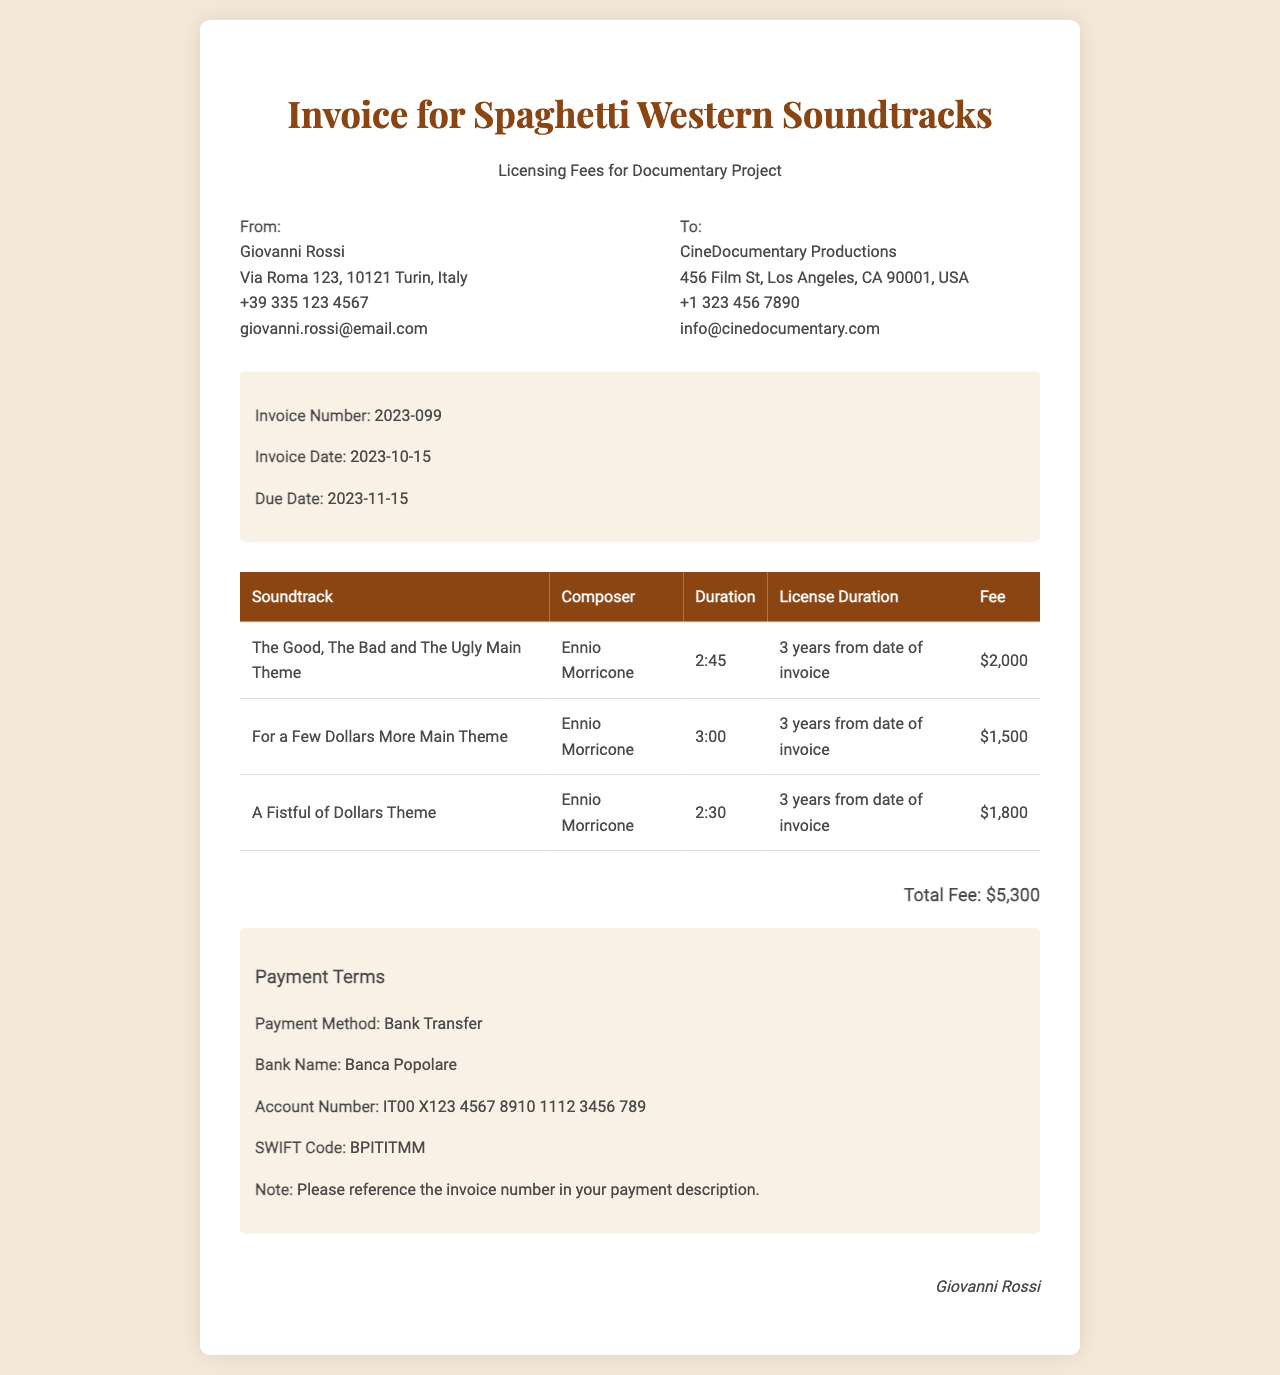What is the invoice number? The invoice number is a unique identifier for this document, listed as 2023-099.
Answer: 2023-099 Who is the composer of "The Good, The Bad and The Ugly Main Theme"? The composer listed for this soundtrack is Ennio Morricone.
Answer: Ennio Morricone What is the total fee for the soundtracks listed? The total fee is the sum of the fees for all soundtracks, which is $2,000 + $1,500 + $1,800 = $5,300.
Answer: $5,300 What is the payment method preferred? The document specifies the payment method as Bank Transfer.
Answer: Bank Transfer How long is the license duration for the soundtracks? The license duration for each soundtrack is stated as 3 years from the date of invoice.
Answer: 3 years from date of invoice When is the due date for the invoice? The due date is the last date by which payment must be made, listed as 2023-11-15.
Answer: 2023-11-15 What is the name of the sender? The sender's name is crucial for identification and is listed as Giovanni Rossi.
Answer: Giovanni Rossi What is the SWIFT code for the bank? The SWIFT code is an important detail for international transactions, listed as BPITITMM.
Answer: BPITITMM 